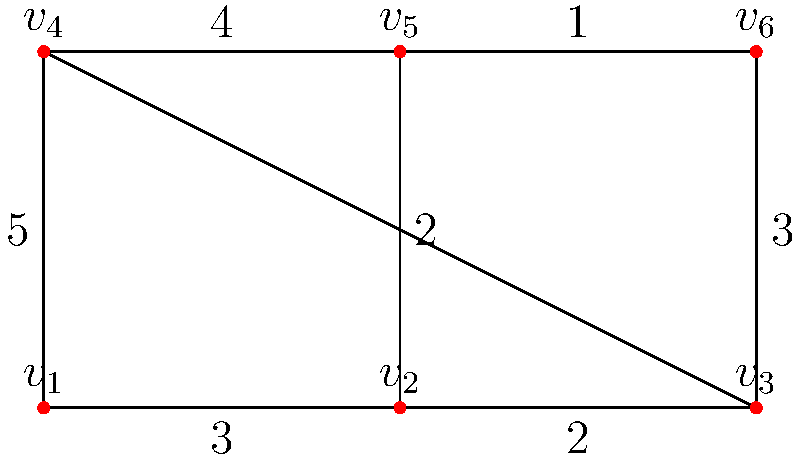As a chocolatier optimizing your production line, you're arranging chocolate molds represented by the vertices in this planar graph. The edges represent conveyor belts, and the numbers indicate the time (in minutes) it takes to move between molds. What is the minimum time required to visit all molds, starting and ending at $v_1$, without revisiting any mold? To solve this problem, we need to find the shortest Hamiltonian cycle in the graph. Let's approach this step-by-step:

1) First, let's list all possible Hamiltonian cycles starting and ending at $v_1$:
   - $v_1 \rightarrow v_2 \rightarrow v_3 \rightarrow v_6 \rightarrow v_5 \rightarrow v_4 \rightarrow v_1$
   - $v_1 \rightarrow v_2 \rightarrow v_5 \rightarrow v_6 \rightarrow v_3 \rightarrow v_4 \rightarrow v_1$
   - $v_1 \rightarrow v_4 \rightarrow v_5 \rightarrow v_2 \rightarrow v_3 \rightarrow v_6 \rightarrow v_1$
   - $v_1 \rightarrow v_4 \rightarrow v_5 \rightarrow v_6 \rightarrow v_3 \rightarrow v_2 \rightarrow v_1$

2) Now, let's calculate the total time for each cycle:
   - Cycle 1: $3 + 2 + 3 + 1 + 4 + 5 = 18$ minutes
   - Cycle 2: $3 + 2 + 1 + 2 + 4 + 5 = 17$ minutes
   - Cycle 3: $5 + 4 + 2 + 2 + 3 + 3 = 19$ minutes
   - Cycle 4: $5 + 4 + 1 + 3 + 2 + 3 = 18$ minutes

3) The minimum time is achieved by Cycle 2, which takes 17 minutes.

Therefore, the minimum time required to visit all molds, starting and ending at $v_1$, without revisiting any mold is 17 minutes.
Answer: 17 minutes 